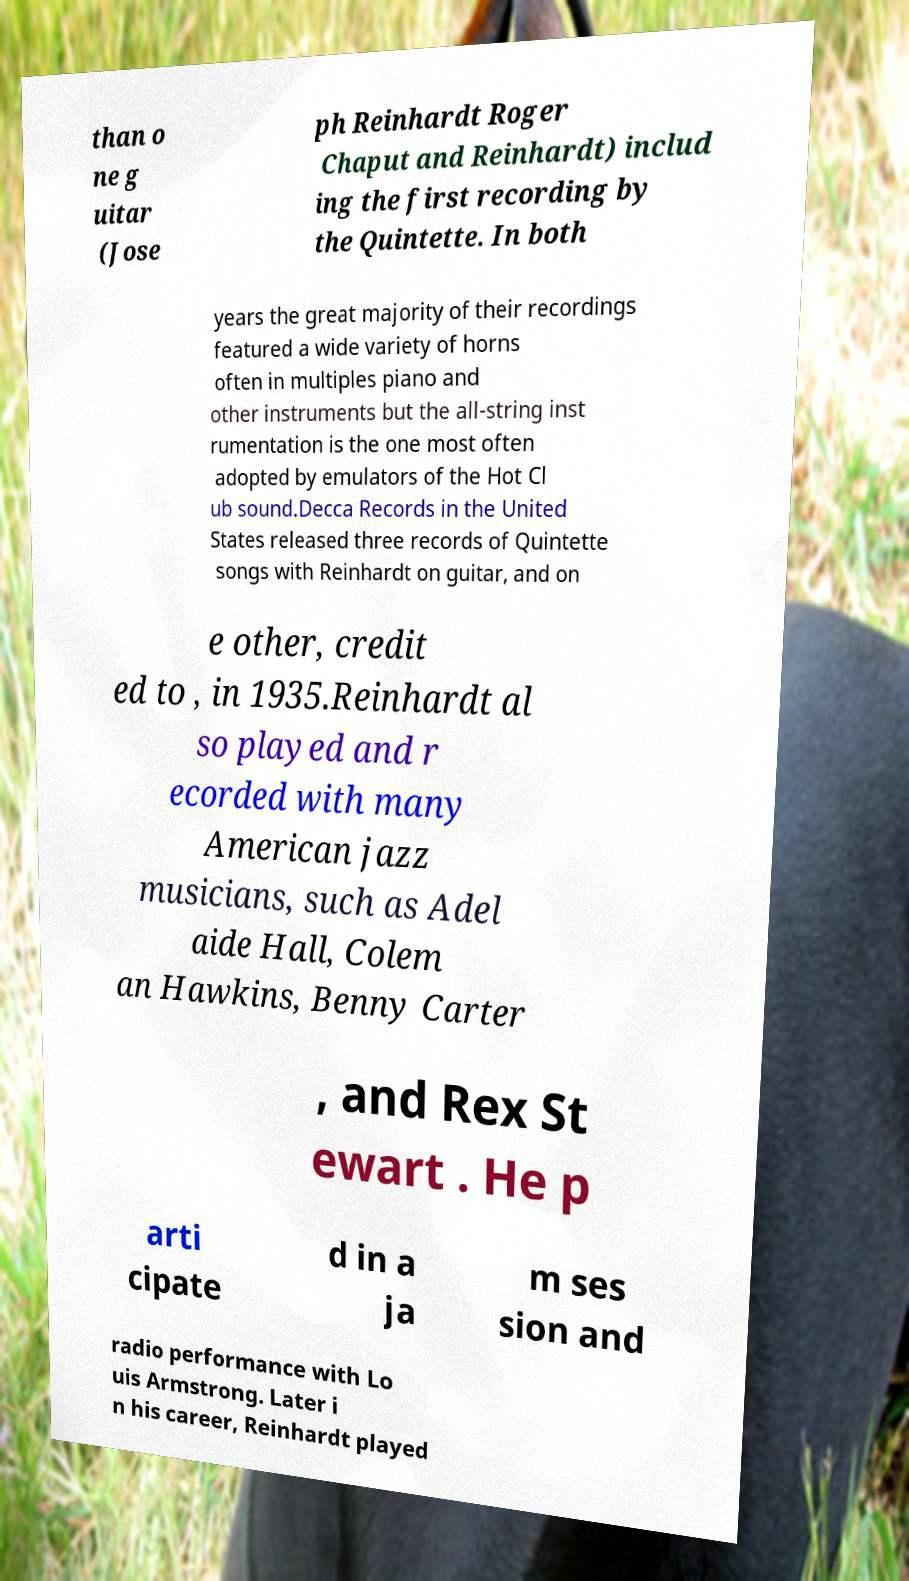I need the written content from this picture converted into text. Can you do that? than o ne g uitar (Jose ph Reinhardt Roger Chaput and Reinhardt) includ ing the first recording by the Quintette. In both years the great majority of their recordings featured a wide variety of horns often in multiples piano and other instruments but the all-string inst rumentation is the one most often adopted by emulators of the Hot Cl ub sound.Decca Records in the United States released three records of Quintette songs with Reinhardt on guitar, and on e other, credit ed to , in 1935.Reinhardt al so played and r ecorded with many American jazz musicians, such as Adel aide Hall, Colem an Hawkins, Benny Carter , and Rex St ewart . He p arti cipate d in a ja m ses sion and radio performance with Lo uis Armstrong. Later i n his career, Reinhardt played 